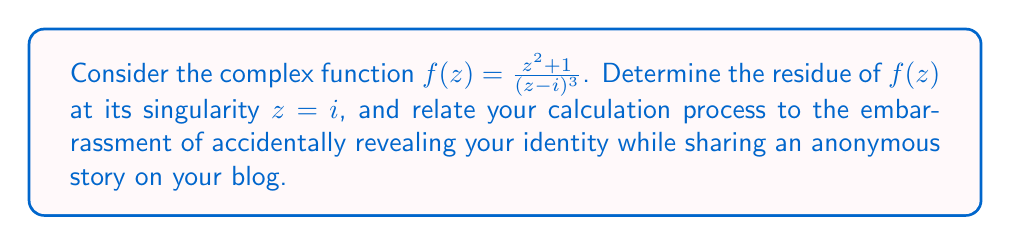Provide a solution to this math problem. To find the residue of $f(z)$ at $z = i$, we need to analyze the singularity and use the appropriate method. In this case, we have a pole of order 3 at $z = i$.

For a pole of order 3, we use the formula:

$$\text{Res}(f, i) = \frac{1}{2!} \lim_{z \to i} \frac{d^2}{dz^2}[(z-i)^3f(z)]$$

Let's break this down step-by-step:

1) First, let's simplify $(z-i)^3f(z)$:
   $$(z-i)^3f(z) = (z-i)^3 \cdot \frac{z^2 + 1}{(z - i)^3} = z^2 + 1$$

2) Now we need to find the second derivative of $z^2 + 1$:
   $$\frac{d}{dz}(z^2 + 1) = 2z$$
   $$\frac{d^2}{dz^2}(z^2 + 1) = 2$$

3) The limit as $z \to i$ of this second derivative is simply 2.

4) Applying the formula:
   $$\text{Res}(f, i) = \frac{1}{2!} \cdot 2 = \frac{1}{2} \cdot 2 = 1$$

This process is similar to accidentally revealing your identity in an anonymous blog post. Just as we peeled back the layers of the function to expose its core (the residue), you might inadvertently peel back the layers of anonymity in your story, exposing your true identity. The residue, like your revealed identity, was there all along, hidden within the complexity of the function (or story).
Answer: The residue of $f(z) = \frac{z^2 + 1}{(z - i)^3}$ at $z = i$ is 1. 